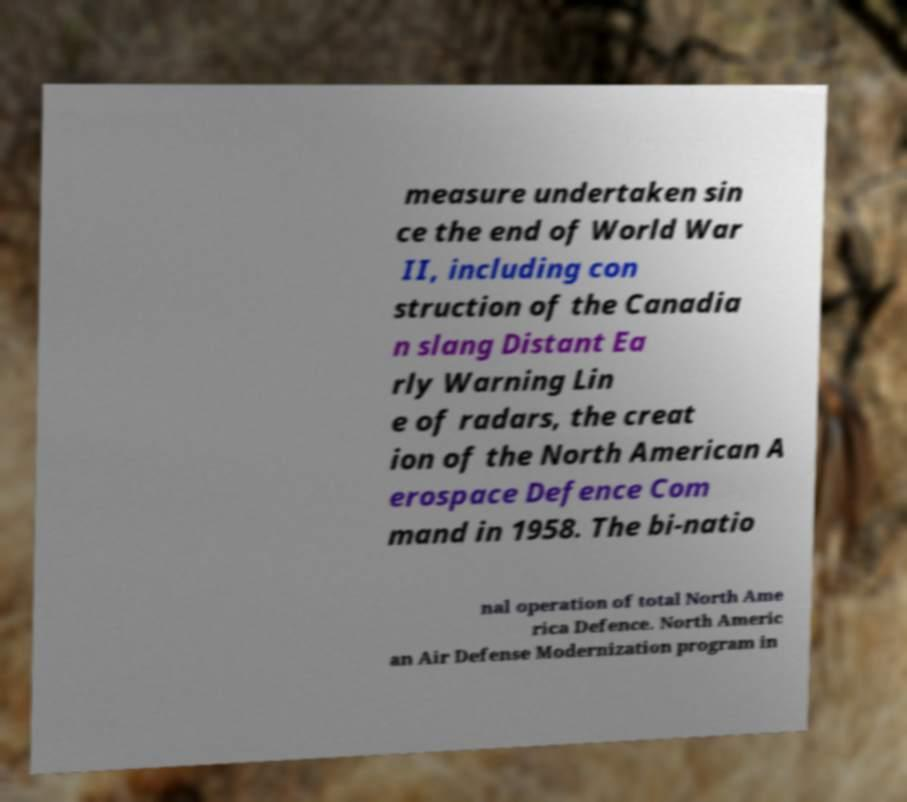For documentation purposes, I need the text within this image transcribed. Could you provide that? measure undertaken sin ce the end of World War II, including con struction of the Canadia n slang Distant Ea rly Warning Lin e of radars, the creat ion of the North American A erospace Defence Com mand in 1958. The bi-natio nal operation of total North Ame rica Defence. North Americ an Air Defense Modernization program in 